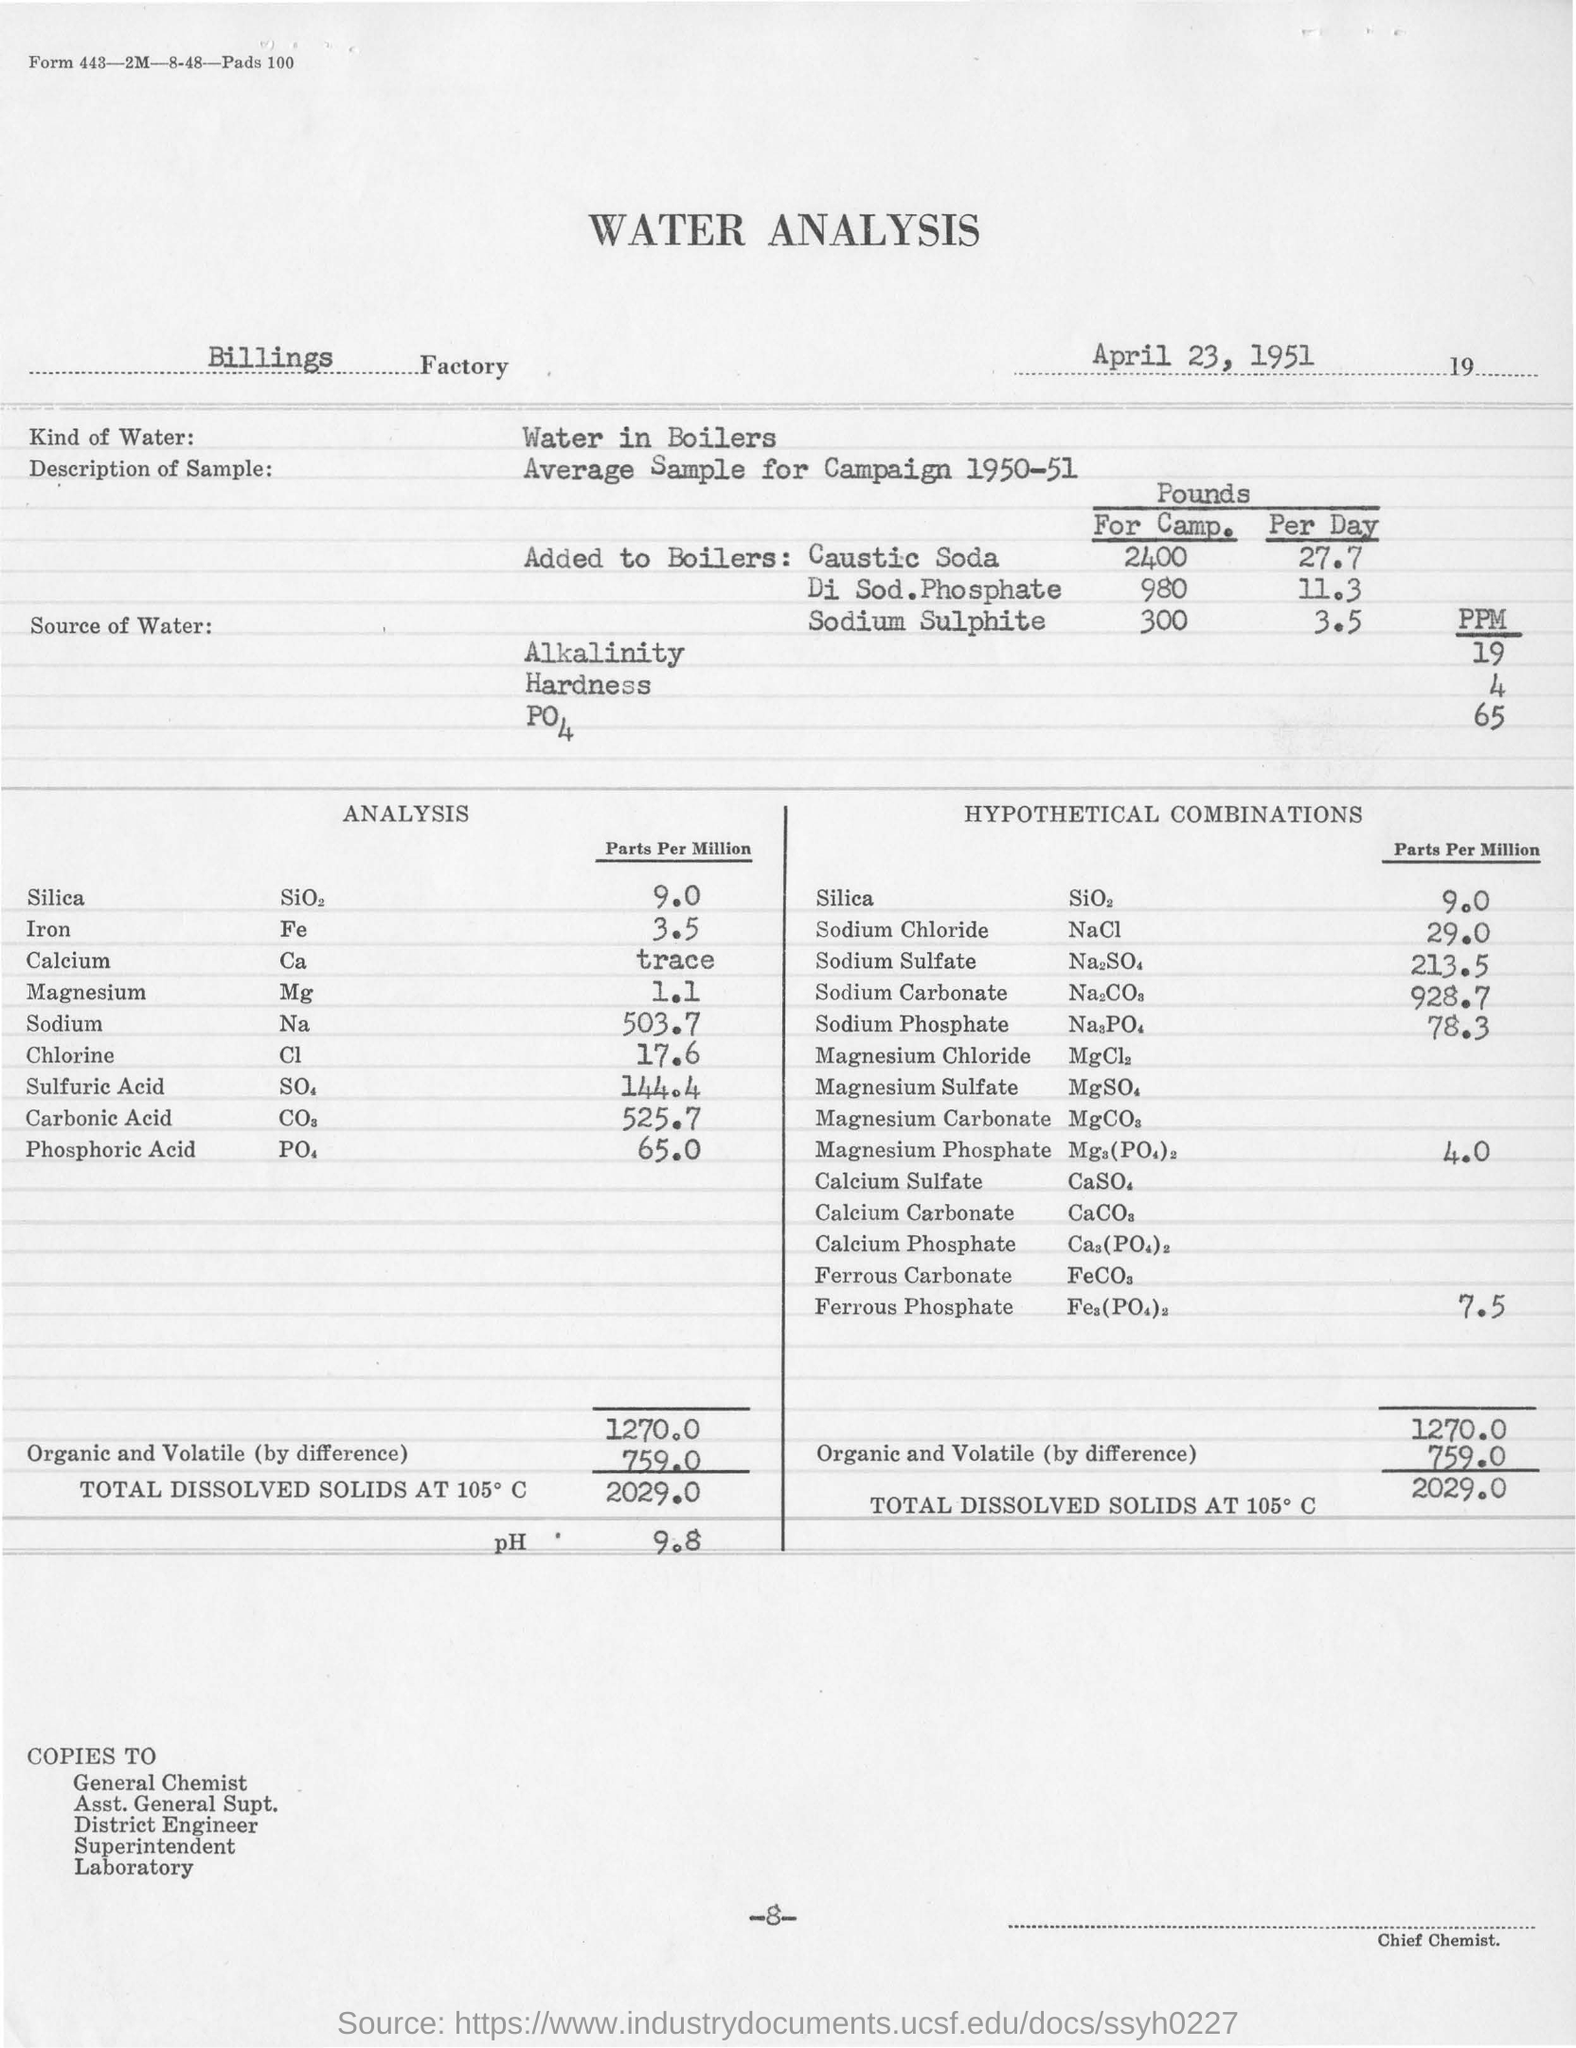What is the kind of water?
Keep it short and to the point. Water in Boilers. What quantity of Chlorine is used for analysis?
Keep it short and to the point. 17.6. In which year is the average sample of water analysis is conducted?
Provide a short and direct response. 1950-51. 